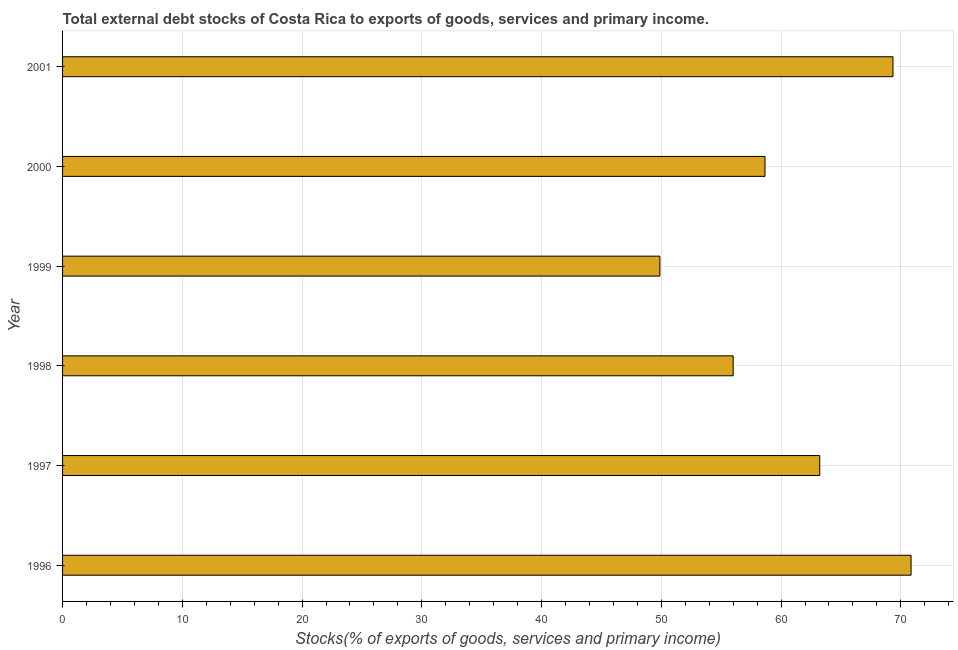Does the graph contain any zero values?
Offer a very short reply. No. What is the title of the graph?
Offer a very short reply. Total external debt stocks of Costa Rica to exports of goods, services and primary income. What is the label or title of the X-axis?
Offer a very short reply. Stocks(% of exports of goods, services and primary income). What is the external debt stocks in 1996?
Make the answer very short. 70.86. Across all years, what is the maximum external debt stocks?
Your answer should be compact. 70.86. Across all years, what is the minimum external debt stocks?
Offer a terse response. 49.88. In which year was the external debt stocks minimum?
Make the answer very short. 1999. What is the sum of the external debt stocks?
Offer a terse response. 367.97. What is the difference between the external debt stocks in 1999 and 2001?
Your answer should be compact. -19.46. What is the average external debt stocks per year?
Offer a very short reply. 61.33. What is the median external debt stocks?
Your answer should be very brief. 60.94. Do a majority of the years between 1999 and 2000 (inclusive) have external debt stocks greater than 4 %?
Your response must be concise. Yes. What is the ratio of the external debt stocks in 1996 to that in 1999?
Provide a short and direct response. 1.42. What is the difference between the highest and the second highest external debt stocks?
Keep it short and to the point. 1.51. What is the difference between the highest and the lowest external debt stocks?
Keep it short and to the point. 20.98. How many bars are there?
Provide a short and direct response. 6. Are all the bars in the graph horizontal?
Your answer should be compact. Yes. Are the values on the major ticks of X-axis written in scientific E-notation?
Your response must be concise. No. What is the Stocks(% of exports of goods, services and primary income) of 1996?
Give a very brief answer. 70.86. What is the Stocks(% of exports of goods, services and primary income) in 1997?
Give a very brief answer. 63.23. What is the Stocks(% of exports of goods, services and primary income) in 1998?
Offer a very short reply. 56. What is the Stocks(% of exports of goods, services and primary income) in 1999?
Give a very brief answer. 49.88. What is the Stocks(% of exports of goods, services and primary income) in 2000?
Give a very brief answer. 58.66. What is the Stocks(% of exports of goods, services and primary income) of 2001?
Your answer should be compact. 69.34. What is the difference between the Stocks(% of exports of goods, services and primary income) in 1996 and 1997?
Keep it short and to the point. 7.62. What is the difference between the Stocks(% of exports of goods, services and primary income) in 1996 and 1998?
Your response must be concise. 14.86. What is the difference between the Stocks(% of exports of goods, services and primary income) in 1996 and 1999?
Make the answer very short. 20.98. What is the difference between the Stocks(% of exports of goods, services and primary income) in 1996 and 2000?
Your response must be concise. 12.2. What is the difference between the Stocks(% of exports of goods, services and primary income) in 1996 and 2001?
Offer a very short reply. 1.51. What is the difference between the Stocks(% of exports of goods, services and primary income) in 1997 and 1998?
Provide a short and direct response. 7.23. What is the difference between the Stocks(% of exports of goods, services and primary income) in 1997 and 1999?
Provide a short and direct response. 13.35. What is the difference between the Stocks(% of exports of goods, services and primary income) in 1997 and 2000?
Your answer should be compact. 4.57. What is the difference between the Stocks(% of exports of goods, services and primary income) in 1997 and 2001?
Offer a very short reply. -6.11. What is the difference between the Stocks(% of exports of goods, services and primary income) in 1998 and 1999?
Keep it short and to the point. 6.12. What is the difference between the Stocks(% of exports of goods, services and primary income) in 1998 and 2000?
Give a very brief answer. -2.66. What is the difference between the Stocks(% of exports of goods, services and primary income) in 1998 and 2001?
Keep it short and to the point. -13.34. What is the difference between the Stocks(% of exports of goods, services and primary income) in 1999 and 2000?
Give a very brief answer. -8.78. What is the difference between the Stocks(% of exports of goods, services and primary income) in 1999 and 2001?
Your answer should be compact. -19.46. What is the difference between the Stocks(% of exports of goods, services and primary income) in 2000 and 2001?
Provide a succinct answer. -10.69. What is the ratio of the Stocks(% of exports of goods, services and primary income) in 1996 to that in 1997?
Your response must be concise. 1.12. What is the ratio of the Stocks(% of exports of goods, services and primary income) in 1996 to that in 1998?
Your answer should be very brief. 1.26. What is the ratio of the Stocks(% of exports of goods, services and primary income) in 1996 to that in 1999?
Keep it short and to the point. 1.42. What is the ratio of the Stocks(% of exports of goods, services and primary income) in 1996 to that in 2000?
Give a very brief answer. 1.21. What is the ratio of the Stocks(% of exports of goods, services and primary income) in 1996 to that in 2001?
Ensure brevity in your answer.  1.02. What is the ratio of the Stocks(% of exports of goods, services and primary income) in 1997 to that in 1998?
Your answer should be very brief. 1.13. What is the ratio of the Stocks(% of exports of goods, services and primary income) in 1997 to that in 1999?
Ensure brevity in your answer.  1.27. What is the ratio of the Stocks(% of exports of goods, services and primary income) in 1997 to that in 2000?
Your answer should be very brief. 1.08. What is the ratio of the Stocks(% of exports of goods, services and primary income) in 1997 to that in 2001?
Provide a succinct answer. 0.91. What is the ratio of the Stocks(% of exports of goods, services and primary income) in 1998 to that in 1999?
Provide a succinct answer. 1.12. What is the ratio of the Stocks(% of exports of goods, services and primary income) in 1998 to that in 2000?
Provide a short and direct response. 0.95. What is the ratio of the Stocks(% of exports of goods, services and primary income) in 1998 to that in 2001?
Keep it short and to the point. 0.81. What is the ratio of the Stocks(% of exports of goods, services and primary income) in 1999 to that in 2001?
Provide a short and direct response. 0.72. What is the ratio of the Stocks(% of exports of goods, services and primary income) in 2000 to that in 2001?
Provide a short and direct response. 0.85. 